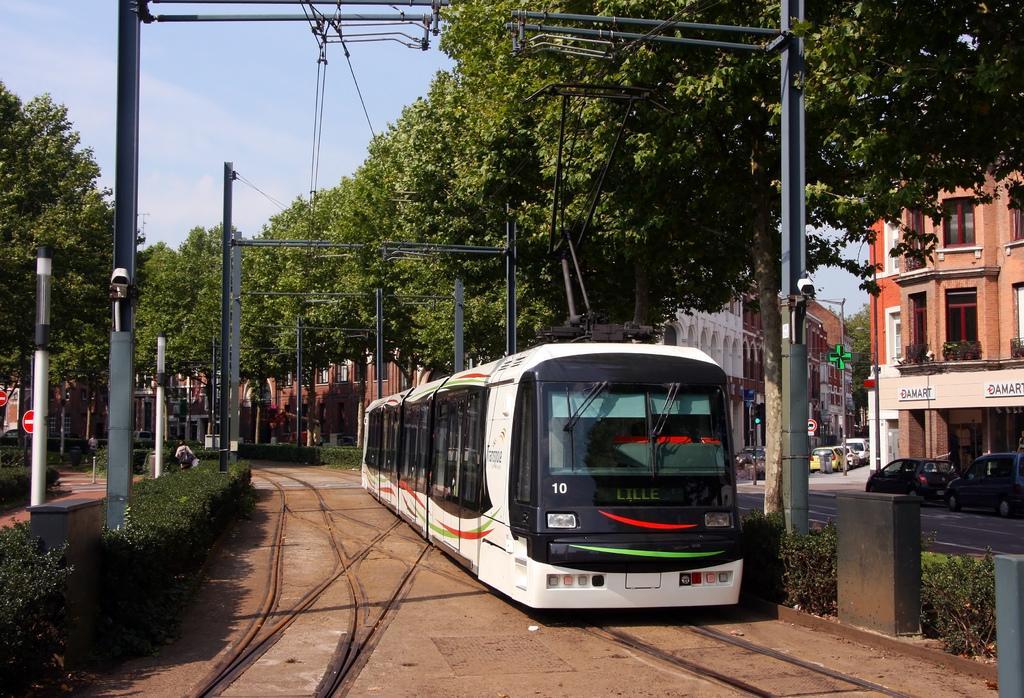Please provide a concise description of this image. In this image in the center there is a train, and on the right side there are some buildings, poles, vehicles, trees and on the left side there are some trees, plants, poles. And in the foreground also there are some poles, at the bottom there is sand and railway track and at the top of the image there is sky. 